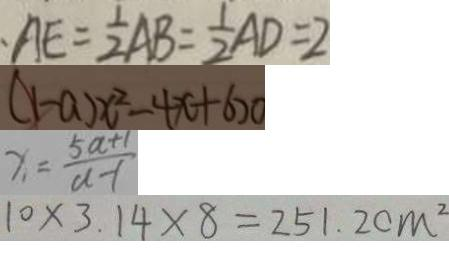Convert formula to latex. <formula><loc_0><loc_0><loc_500><loc_500>A E = \frac { 1 } { 2 } A B = \frac { 1 } { 2 } A D = 2 
 ( 1 - a ) x ^ { 2 } - 4 x + 6 > 0 
 x = \frac { 5 a + 1 } { a - 1 } 
 1 0 \times 3 . 1 4 \times 8 = 2 5 1 . 2 c m ^ { 2 }</formula> 